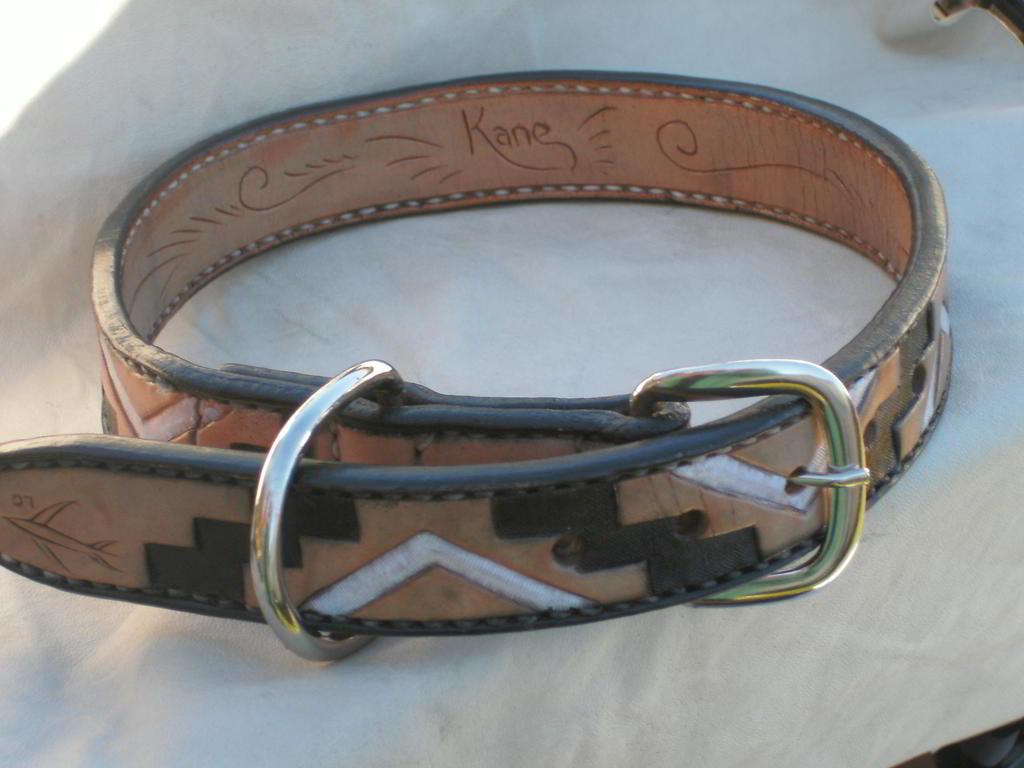What name is written on this belt?
Your response must be concise. Kane. 